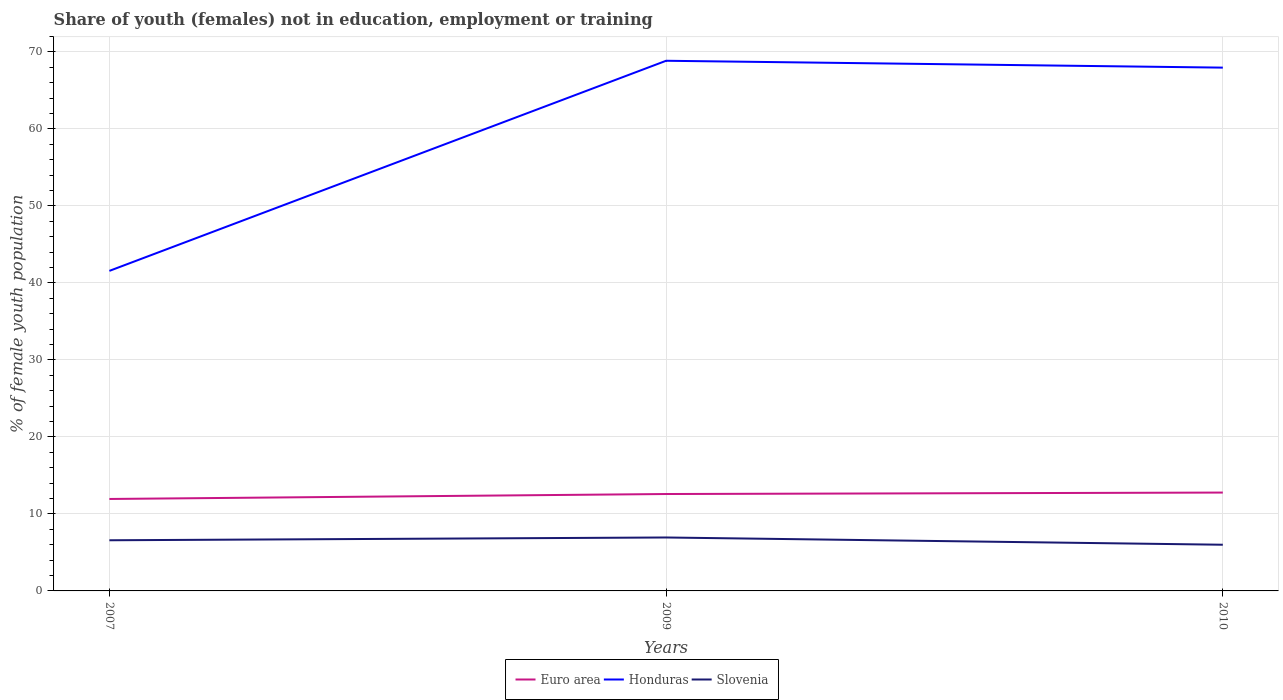How many different coloured lines are there?
Give a very brief answer. 3. Does the line corresponding to Honduras intersect with the line corresponding to Euro area?
Ensure brevity in your answer.  No. Is the number of lines equal to the number of legend labels?
Offer a terse response. Yes. Across all years, what is the maximum percentage of unemployed female population in in Euro area?
Make the answer very short. 11.94. In which year was the percentage of unemployed female population in in Slovenia maximum?
Your answer should be very brief. 2010. What is the total percentage of unemployed female population in in Slovenia in the graph?
Your answer should be compact. 0.58. What is the difference between the highest and the second highest percentage of unemployed female population in in Euro area?
Make the answer very short. 0.83. What is the difference between the highest and the lowest percentage of unemployed female population in in Honduras?
Your answer should be very brief. 2. Is the percentage of unemployed female population in in Honduras strictly greater than the percentage of unemployed female population in in Slovenia over the years?
Offer a terse response. No. How many lines are there?
Give a very brief answer. 3. What is the difference between two consecutive major ticks on the Y-axis?
Ensure brevity in your answer.  10. Does the graph contain any zero values?
Provide a short and direct response. No. Does the graph contain grids?
Provide a succinct answer. Yes. How are the legend labels stacked?
Offer a very short reply. Horizontal. What is the title of the graph?
Keep it short and to the point. Share of youth (females) not in education, employment or training. Does "Micronesia" appear as one of the legend labels in the graph?
Ensure brevity in your answer.  No. What is the label or title of the X-axis?
Offer a terse response. Years. What is the label or title of the Y-axis?
Offer a very short reply. % of female youth population. What is the % of female youth population in Euro area in 2007?
Offer a terse response. 11.94. What is the % of female youth population in Honduras in 2007?
Provide a succinct answer. 41.57. What is the % of female youth population in Slovenia in 2007?
Provide a short and direct response. 6.58. What is the % of female youth population in Euro area in 2009?
Your response must be concise. 12.59. What is the % of female youth population in Honduras in 2009?
Ensure brevity in your answer.  68.86. What is the % of female youth population of Slovenia in 2009?
Offer a terse response. 6.94. What is the % of female youth population of Euro area in 2010?
Your response must be concise. 12.78. What is the % of female youth population in Honduras in 2010?
Make the answer very short. 67.97. Across all years, what is the maximum % of female youth population of Euro area?
Ensure brevity in your answer.  12.78. Across all years, what is the maximum % of female youth population in Honduras?
Give a very brief answer. 68.86. Across all years, what is the maximum % of female youth population in Slovenia?
Ensure brevity in your answer.  6.94. Across all years, what is the minimum % of female youth population in Euro area?
Provide a succinct answer. 11.94. Across all years, what is the minimum % of female youth population of Honduras?
Your answer should be compact. 41.57. What is the total % of female youth population in Euro area in the graph?
Give a very brief answer. 37.31. What is the total % of female youth population in Honduras in the graph?
Offer a very short reply. 178.4. What is the total % of female youth population in Slovenia in the graph?
Your answer should be compact. 19.52. What is the difference between the % of female youth population of Euro area in 2007 and that in 2009?
Your answer should be very brief. -0.64. What is the difference between the % of female youth population in Honduras in 2007 and that in 2009?
Your answer should be compact. -27.29. What is the difference between the % of female youth population in Slovenia in 2007 and that in 2009?
Keep it short and to the point. -0.36. What is the difference between the % of female youth population of Euro area in 2007 and that in 2010?
Make the answer very short. -0.83. What is the difference between the % of female youth population of Honduras in 2007 and that in 2010?
Make the answer very short. -26.4. What is the difference between the % of female youth population in Slovenia in 2007 and that in 2010?
Give a very brief answer. 0.58. What is the difference between the % of female youth population of Euro area in 2009 and that in 2010?
Your answer should be compact. -0.19. What is the difference between the % of female youth population in Honduras in 2009 and that in 2010?
Offer a terse response. 0.89. What is the difference between the % of female youth population of Euro area in 2007 and the % of female youth population of Honduras in 2009?
Provide a short and direct response. -56.92. What is the difference between the % of female youth population in Euro area in 2007 and the % of female youth population in Slovenia in 2009?
Your answer should be compact. 5. What is the difference between the % of female youth population of Honduras in 2007 and the % of female youth population of Slovenia in 2009?
Offer a terse response. 34.63. What is the difference between the % of female youth population of Euro area in 2007 and the % of female youth population of Honduras in 2010?
Your answer should be compact. -56.03. What is the difference between the % of female youth population in Euro area in 2007 and the % of female youth population in Slovenia in 2010?
Ensure brevity in your answer.  5.94. What is the difference between the % of female youth population of Honduras in 2007 and the % of female youth population of Slovenia in 2010?
Ensure brevity in your answer.  35.57. What is the difference between the % of female youth population of Euro area in 2009 and the % of female youth population of Honduras in 2010?
Offer a terse response. -55.38. What is the difference between the % of female youth population in Euro area in 2009 and the % of female youth population in Slovenia in 2010?
Your answer should be compact. 6.59. What is the difference between the % of female youth population of Honduras in 2009 and the % of female youth population of Slovenia in 2010?
Provide a short and direct response. 62.86. What is the average % of female youth population in Euro area per year?
Your answer should be very brief. 12.44. What is the average % of female youth population in Honduras per year?
Keep it short and to the point. 59.47. What is the average % of female youth population of Slovenia per year?
Your answer should be very brief. 6.51. In the year 2007, what is the difference between the % of female youth population of Euro area and % of female youth population of Honduras?
Your answer should be very brief. -29.63. In the year 2007, what is the difference between the % of female youth population in Euro area and % of female youth population in Slovenia?
Provide a succinct answer. 5.36. In the year 2007, what is the difference between the % of female youth population in Honduras and % of female youth population in Slovenia?
Provide a short and direct response. 34.99. In the year 2009, what is the difference between the % of female youth population in Euro area and % of female youth population in Honduras?
Your response must be concise. -56.27. In the year 2009, what is the difference between the % of female youth population in Euro area and % of female youth population in Slovenia?
Offer a terse response. 5.65. In the year 2009, what is the difference between the % of female youth population of Honduras and % of female youth population of Slovenia?
Provide a succinct answer. 61.92. In the year 2010, what is the difference between the % of female youth population of Euro area and % of female youth population of Honduras?
Offer a very short reply. -55.19. In the year 2010, what is the difference between the % of female youth population in Euro area and % of female youth population in Slovenia?
Your answer should be compact. 6.78. In the year 2010, what is the difference between the % of female youth population of Honduras and % of female youth population of Slovenia?
Your response must be concise. 61.97. What is the ratio of the % of female youth population of Euro area in 2007 to that in 2009?
Your answer should be very brief. 0.95. What is the ratio of the % of female youth population of Honduras in 2007 to that in 2009?
Your answer should be compact. 0.6. What is the ratio of the % of female youth population of Slovenia in 2007 to that in 2009?
Keep it short and to the point. 0.95. What is the ratio of the % of female youth population of Euro area in 2007 to that in 2010?
Provide a short and direct response. 0.93. What is the ratio of the % of female youth population of Honduras in 2007 to that in 2010?
Provide a succinct answer. 0.61. What is the ratio of the % of female youth population of Slovenia in 2007 to that in 2010?
Your answer should be compact. 1.1. What is the ratio of the % of female youth population of Euro area in 2009 to that in 2010?
Provide a succinct answer. 0.99. What is the ratio of the % of female youth population of Honduras in 2009 to that in 2010?
Your answer should be very brief. 1.01. What is the ratio of the % of female youth population in Slovenia in 2009 to that in 2010?
Give a very brief answer. 1.16. What is the difference between the highest and the second highest % of female youth population in Euro area?
Provide a succinct answer. 0.19. What is the difference between the highest and the second highest % of female youth population in Honduras?
Your response must be concise. 0.89. What is the difference between the highest and the second highest % of female youth population in Slovenia?
Your response must be concise. 0.36. What is the difference between the highest and the lowest % of female youth population in Euro area?
Offer a terse response. 0.83. What is the difference between the highest and the lowest % of female youth population of Honduras?
Keep it short and to the point. 27.29. What is the difference between the highest and the lowest % of female youth population in Slovenia?
Your answer should be very brief. 0.94. 